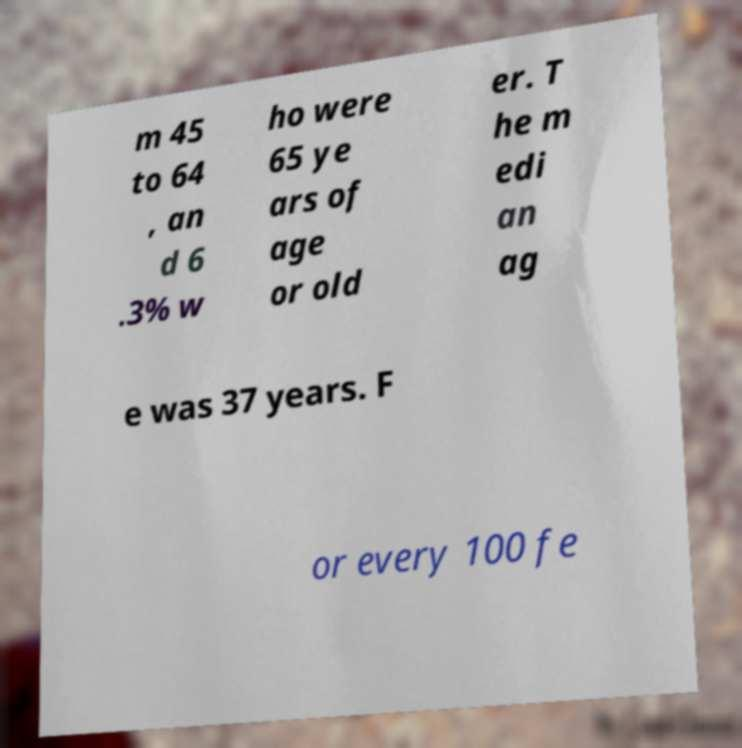Could you extract and type out the text from this image? m 45 to 64 , an d 6 .3% w ho were 65 ye ars of age or old er. T he m edi an ag e was 37 years. F or every 100 fe 